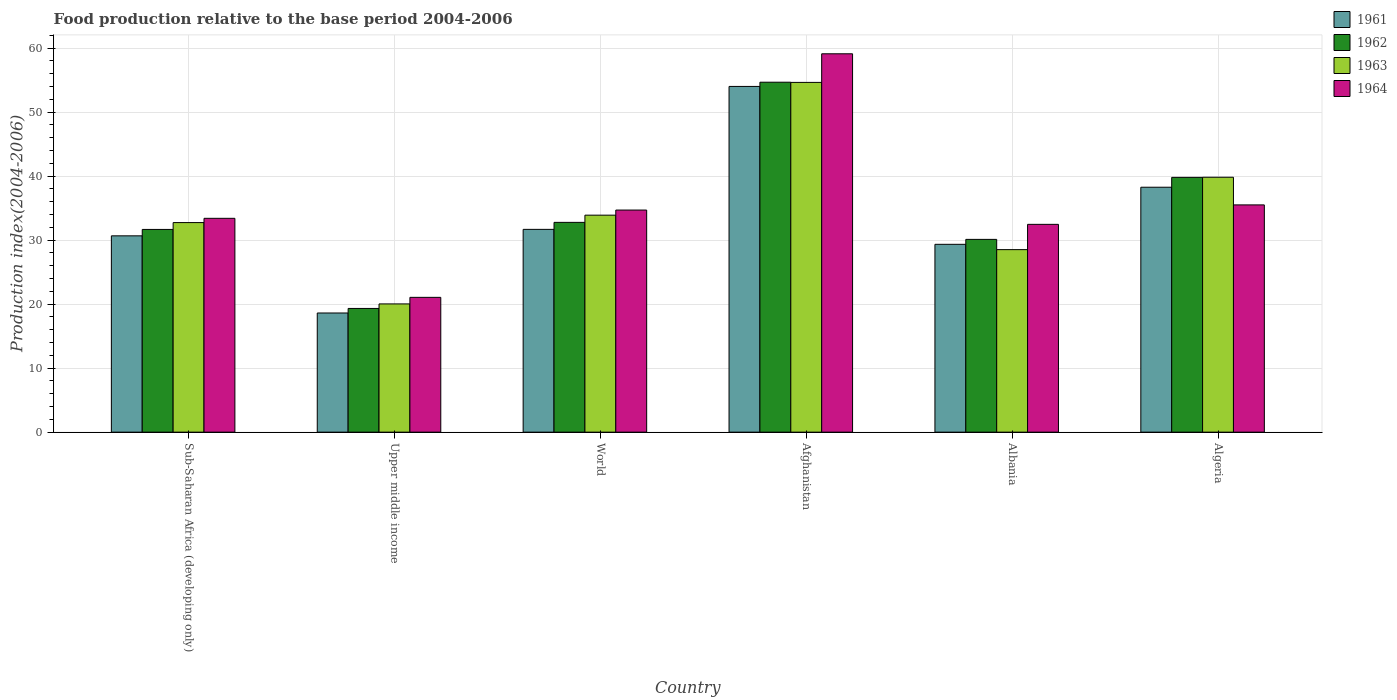How many different coloured bars are there?
Your response must be concise. 4. Are the number of bars per tick equal to the number of legend labels?
Keep it short and to the point. Yes. How many bars are there on the 2nd tick from the left?
Offer a very short reply. 4. How many bars are there on the 1st tick from the right?
Provide a succinct answer. 4. What is the label of the 4th group of bars from the left?
Your answer should be compact. Afghanistan. In how many cases, is the number of bars for a given country not equal to the number of legend labels?
Your answer should be compact. 0. What is the food production index in 1961 in Algeria?
Your response must be concise. 38.27. Across all countries, what is the maximum food production index in 1962?
Offer a very short reply. 54.68. Across all countries, what is the minimum food production index in 1963?
Provide a succinct answer. 20.04. In which country was the food production index in 1961 maximum?
Offer a terse response. Afghanistan. In which country was the food production index in 1963 minimum?
Give a very brief answer. Upper middle income. What is the total food production index in 1963 in the graph?
Give a very brief answer. 209.69. What is the difference between the food production index in 1963 in Sub-Saharan Africa (developing only) and that in World?
Give a very brief answer. -1.16. What is the difference between the food production index in 1964 in Algeria and the food production index in 1962 in Albania?
Give a very brief answer. 5.39. What is the average food production index in 1961 per country?
Offer a very short reply. 33.77. What is the difference between the food production index of/in 1961 and food production index of/in 1964 in World?
Provide a short and direct response. -3.02. What is the ratio of the food production index in 1962 in Upper middle income to that in World?
Ensure brevity in your answer.  0.59. What is the difference between the highest and the second highest food production index in 1961?
Your answer should be very brief. -15.75. What is the difference between the highest and the lowest food production index in 1961?
Give a very brief answer. 35.4. In how many countries, is the food production index in 1962 greater than the average food production index in 1962 taken over all countries?
Keep it short and to the point. 2. Is the sum of the food production index in 1963 in Afghanistan and World greater than the maximum food production index in 1961 across all countries?
Make the answer very short. Yes. Is it the case that in every country, the sum of the food production index in 1963 and food production index in 1961 is greater than the sum of food production index in 1962 and food production index in 1964?
Ensure brevity in your answer.  No. What does the 1st bar from the right in World represents?
Your answer should be compact. 1964. Is it the case that in every country, the sum of the food production index in 1962 and food production index in 1964 is greater than the food production index in 1963?
Ensure brevity in your answer.  Yes. How many bars are there?
Keep it short and to the point. 24. How many countries are there in the graph?
Give a very brief answer. 6. Are the values on the major ticks of Y-axis written in scientific E-notation?
Offer a terse response. No. Where does the legend appear in the graph?
Make the answer very short. Top right. How many legend labels are there?
Provide a succinct answer. 4. How are the legend labels stacked?
Ensure brevity in your answer.  Vertical. What is the title of the graph?
Your answer should be compact. Food production relative to the base period 2004-2006. Does "2003" appear as one of the legend labels in the graph?
Give a very brief answer. No. What is the label or title of the Y-axis?
Provide a short and direct response. Production index(2004-2006). What is the Production index(2004-2006) of 1961 in Sub-Saharan Africa (developing only)?
Provide a short and direct response. 30.68. What is the Production index(2004-2006) in 1962 in Sub-Saharan Africa (developing only)?
Your answer should be compact. 31.68. What is the Production index(2004-2006) of 1963 in Sub-Saharan Africa (developing only)?
Offer a very short reply. 32.75. What is the Production index(2004-2006) in 1964 in Sub-Saharan Africa (developing only)?
Ensure brevity in your answer.  33.41. What is the Production index(2004-2006) of 1961 in Upper middle income?
Provide a succinct answer. 18.62. What is the Production index(2004-2006) in 1962 in Upper middle income?
Provide a short and direct response. 19.33. What is the Production index(2004-2006) of 1963 in Upper middle income?
Offer a terse response. 20.04. What is the Production index(2004-2006) in 1964 in Upper middle income?
Offer a terse response. 21.06. What is the Production index(2004-2006) of 1961 in World?
Your response must be concise. 31.69. What is the Production index(2004-2006) in 1962 in World?
Your answer should be compact. 32.78. What is the Production index(2004-2006) of 1963 in World?
Offer a very short reply. 33.91. What is the Production index(2004-2006) in 1964 in World?
Your answer should be very brief. 34.7. What is the Production index(2004-2006) in 1961 in Afghanistan?
Offer a very short reply. 54.02. What is the Production index(2004-2006) of 1962 in Afghanistan?
Give a very brief answer. 54.68. What is the Production index(2004-2006) in 1963 in Afghanistan?
Provide a succinct answer. 54.65. What is the Production index(2004-2006) in 1964 in Afghanistan?
Provide a short and direct response. 59.12. What is the Production index(2004-2006) of 1961 in Albania?
Provide a short and direct response. 29.35. What is the Production index(2004-2006) in 1962 in Albania?
Provide a succinct answer. 30.12. What is the Production index(2004-2006) of 1963 in Albania?
Keep it short and to the point. 28.52. What is the Production index(2004-2006) of 1964 in Albania?
Make the answer very short. 32.47. What is the Production index(2004-2006) of 1961 in Algeria?
Ensure brevity in your answer.  38.27. What is the Production index(2004-2006) in 1962 in Algeria?
Offer a very short reply. 39.81. What is the Production index(2004-2006) of 1963 in Algeria?
Your answer should be very brief. 39.83. What is the Production index(2004-2006) of 1964 in Algeria?
Keep it short and to the point. 35.51. Across all countries, what is the maximum Production index(2004-2006) of 1961?
Your answer should be compact. 54.02. Across all countries, what is the maximum Production index(2004-2006) of 1962?
Ensure brevity in your answer.  54.68. Across all countries, what is the maximum Production index(2004-2006) in 1963?
Provide a succinct answer. 54.65. Across all countries, what is the maximum Production index(2004-2006) in 1964?
Provide a succinct answer. 59.12. Across all countries, what is the minimum Production index(2004-2006) of 1961?
Offer a very short reply. 18.62. Across all countries, what is the minimum Production index(2004-2006) of 1962?
Offer a very short reply. 19.33. Across all countries, what is the minimum Production index(2004-2006) in 1963?
Provide a short and direct response. 20.04. Across all countries, what is the minimum Production index(2004-2006) of 1964?
Make the answer very short. 21.06. What is the total Production index(2004-2006) in 1961 in the graph?
Provide a succinct answer. 202.62. What is the total Production index(2004-2006) of 1962 in the graph?
Give a very brief answer. 208.39. What is the total Production index(2004-2006) of 1963 in the graph?
Make the answer very short. 209.69. What is the total Production index(2004-2006) of 1964 in the graph?
Provide a succinct answer. 216.28. What is the difference between the Production index(2004-2006) of 1961 in Sub-Saharan Africa (developing only) and that in Upper middle income?
Your answer should be compact. 12.06. What is the difference between the Production index(2004-2006) in 1962 in Sub-Saharan Africa (developing only) and that in Upper middle income?
Provide a succinct answer. 12.35. What is the difference between the Production index(2004-2006) of 1963 in Sub-Saharan Africa (developing only) and that in Upper middle income?
Your response must be concise. 12.71. What is the difference between the Production index(2004-2006) of 1964 in Sub-Saharan Africa (developing only) and that in Upper middle income?
Your answer should be compact. 12.35. What is the difference between the Production index(2004-2006) of 1961 in Sub-Saharan Africa (developing only) and that in World?
Give a very brief answer. -1.01. What is the difference between the Production index(2004-2006) in 1962 in Sub-Saharan Africa (developing only) and that in World?
Provide a succinct answer. -1.1. What is the difference between the Production index(2004-2006) in 1963 in Sub-Saharan Africa (developing only) and that in World?
Your answer should be compact. -1.16. What is the difference between the Production index(2004-2006) of 1964 in Sub-Saharan Africa (developing only) and that in World?
Ensure brevity in your answer.  -1.29. What is the difference between the Production index(2004-2006) in 1961 in Sub-Saharan Africa (developing only) and that in Afghanistan?
Provide a succinct answer. -23.34. What is the difference between the Production index(2004-2006) of 1962 in Sub-Saharan Africa (developing only) and that in Afghanistan?
Your response must be concise. -23. What is the difference between the Production index(2004-2006) of 1963 in Sub-Saharan Africa (developing only) and that in Afghanistan?
Your answer should be compact. -21.91. What is the difference between the Production index(2004-2006) in 1964 in Sub-Saharan Africa (developing only) and that in Afghanistan?
Provide a succinct answer. -25.71. What is the difference between the Production index(2004-2006) in 1961 in Sub-Saharan Africa (developing only) and that in Albania?
Provide a succinct answer. 1.33. What is the difference between the Production index(2004-2006) in 1962 in Sub-Saharan Africa (developing only) and that in Albania?
Your answer should be very brief. 1.56. What is the difference between the Production index(2004-2006) of 1963 in Sub-Saharan Africa (developing only) and that in Albania?
Provide a succinct answer. 4.22. What is the difference between the Production index(2004-2006) in 1964 in Sub-Saharan Africa (developing only) and that in Albania?
Make the answer very short. 0.94. What is the difference between the Production index(2004-2006) in 1961 in Sub-Saharan Africa (developing only) and that in Algeria?
Your answer should be compact. -7.59. What is the difference between the Production index(2004-2006) in 1962 in Sub-Saharan Africa (developing only) and that in Algeria?
Give a very brief answer. -8.13. What is the difference between the Production index(2004-2006) of 1963 in Sub-Saharan Africa (developing only) and that in Algeria?
Ensure brevity in your answer.  -7.08. What is the difference between the Production index(2004-2006) of 1964 in Sub-Saharan Africa (developing only) and that in Algeria?
Your answer should be very brief. -2.1. What is the difference between the Production index(2004-2006) in 1961 in Upper middle income and that in World?
Ensure brevity in your answer.  -13.07. What is the difference between the Production index(2004-2006) of 1962 in Upper middle income and that in World?
Keep it short and to the point. -13.45. What is the difference between the Production index(2004-2006) in 1963 in Upper middle income and that in World?
Ensure brevity in your answer.  -13.87. What is the difference between the Production index(2004-2006) of 1964 in Upper middle income and that in World?
Keep it short and to the point. -13.64. What is the difference between the Production index(2004-2006) in 1961 in Upper middle income and that in Afghanistan?
Keep it short and to the point. -35.4. What is the difference between the Production index(2004-2006) in 1962 in Upper middle income and that in Afghanistan?
Provide a succinct answer. -35.35. What is the difference between the Production index(2004-2006) in 1963 in Upper middle income and that in Afghanistan?
Offer a terse response. -34.61. What is the difference between the Production index(2004-2006) of 1964 in Upper middle income and that in Afghanistan?
Your answer should be very brief. -38.06. What is the difference between the Production index(2004-2006) of 1961 in Upper middle income and that in Albania?
Your answer should be compact. -10.73. What is the difference between the Production index(2004-2006) of 1962 in Upper middle income and that in Albania?
Offer a terse response. -10.79. What is the difference between the Production index(2004-2006) in 1963 in Upper middle income and that in Albania?
Ensure brevity in your answer.  -8.48. What is the difference between the Production index(2004-2006) of 1964 in Upper middle income and that in Albania?
Offer a very short reply. -11.41. What is the difference between the Production index(2004-2006) in 1961 in Upper middle income and that in Algeria?
Offer a terse response. -19.65. What is the difference between the Production index(2004-2006) in 1962 in Upper middle income and that in Algeria?
Your answer should be compact. -20.48. What is the difference between the Production index(2004-2006) in 1963 in Upper middle income and that in Algeria?
Provide a succinct answer. -19.79. What is the difference between the Production index(2004-2006) of 1964 in Upper middle income and that in Algeria?
Give a very brief answer. -14.45. What is the difference between the Production index(2004-2006) in 1961 in World and that in Afghanistan?
Offer a very short reply. -22.33. What is the difference between the Production index(2004-2006) in 1962 in World and that in Afghanistan?
Offer a very short reply. -21.9. What is the difference between the Production index(2004-2006) in 1963 in World and that in Afghanistan?
Provide a succinct answer. -20.74. What is the difference between the Production index(2004-2006) of 1964 in World and that in Afghanistan?
Keep it short and to the point. -24.42. What is the difference between the Production index(2004-2006) in 1961 in World and that in Albania?
Offer a very short reply. 2.34. What is the difference between the Production index(2004-2006) in 1962 in World and that in Albania?
Your answer should be very brief. 2.66. What is the difference between the Production index(2004-2006) in 1963 in World and that in Albania?
Offer a very short reply. 5.39. What is the difference between the Production index(2004-2006) of 1964 in World and that in Albania?
Your response must be concise. 2.23. What is the difference between the Production index(2004-2006) in 1961 in World and that in Algeria?
Ensure brevity in your answer.  -6.58. What is the difference between the Production index(2004-2006) of 1962 in World and that in Algeria?
Provide a short and direct response. -7.03. What is the difference between the Production index(2004-2006) of 1963 in World and that in Algeria?
Offer a terse response. -5.92. What is the difference between the Production index(2004-2006) of 1964 in World and that in Algeria?
Give a very brief answer. -0.81. What is the difference between the Production index(2004-2006) in 1961 in Afghanistan and that in Albania?
Your response must be concise. 24.67. What is the difference between the Production index(2004-2006) of 1962 in Afghanistan and that in Albania?
Provide a succinct answer. 24.56. What is the difference between the Production index(2004-2006) in 1963 in Afghanistan and that in Albania?
Ensure brevity in your answer.  26.13. What is the difference between the Production index(2004-2006) of 1964 in Afghanistan and that in Albania?
Your answer should be compact. 26.65. What is the difference between the Production index(2004-2006) of 1961 in Afghanistan and that in Algeria?
Keep it short and to the point. 15.75. What is the difference between the Production index(2004-2006) in 1962 in Afghanistan and that in Algeria?
Provide a short and direct response. 14.87. What is the difference between the Production index(2004-2006) in 1963 in Afghanistan and that in Algeria?
Provide a short and direct response. 14.82. What is the difference between the Production index(2004-2006) in 1964 in Afghanistan and that in Algeria?
Your answer should be very brief. 23.61. What is the difference between the Production index(2004-2006) in 1961 in Albania and that in Algeria?
Offer a terse response. -8.92. What is the difference between the Production index(2004-2006) in 1962 in Albania and that in Algeria?
Your answer should be compact. -9.69. What is the difference between the Production index(2004-2006) of 1963 in Albania and that in Algeria?
Ensure brevity in your answer.  -11.31. What is the difference between the Production index(2004-2006) in 1964 in Albania and that in Algeria?
Your response must be concise. -3.04. What is the difference between the Production index(2004-2006) of 1961 in Sub-Saharan Africa (developing only) and the Production index(2004-2006) of 1962 in Upper middle income?
Your answer should be compact. 11.35. What is the difference between the Production index(2004-2006) of 1961 in Sub-Saharan Africa (developing only) and the Production index(2004-2006) of 1963 in Upper middle income?
Keep it short and to the point. 10.64. What is the difference between the Production index(2004-2006) in 1961 in Sub-Saharan Africa (developing only) and the Production index(2004-2006) in 1964 in Upper middle income?
Your answer should be compact. 9.61. What is the difference between the Production index(2004-2006) of 1962 in Sub-Saharan Africa (developing only) and the Production index(2004-2006) of 1963 in Upper middle income?
Your answer should be compact. 11.64. What is the difference between the Production index(2004-2006) of 1962 in Sub-Saharan Africa (developing only) and the Production index(2004-2006) of 1964 in Upper middle income?
Your answer should be very brief. 10.61. What is the difference between the Production index(2004-2006) in 1963 in Sub-Saharan Africa (developing only) and the Production index(2004-2006) in 1964 in Upper middle income?
Keep it short and to the point. 11.68. What is the difference between the Production index(2004-2006) of 1961 in Sub-Saharan Africa (developing only) and the Production index(2004-2006) of 1962 in World?
Your answer should be very brief. -2.1. What is the difference between the Production index(2004-2006) of 1961 in Sub-Saharan Africa (developing only) and the Production index(2004-2006) of 1963 in World?
Provide a succinct answer. -3.23. What is the difference between the Production index(2004-2006) in 1961 in Sub-Saharan Africa (developing only) and the Production index(2004-2006) in 1964 in World?
Give a very brief answer. -4.03. What is the difference between the Production index(2004-2006) of 1962 in Sub-Saharan Africa (developing only) and the Production index(2004-2006) of 1963 in World?
Ensure brevity in your answer.  -2.23. What is the difference between the Production index(2004-2006) of 1962 in Sub-Saharan Africa (developing only) and the Production index(2004-2006) of 1964 in World?
Offer a terse response. -3.03. What is the difference between the Production index(2004-2006) of 1963 in Sub-Saharan Africa (developing only) and the Production index(2004-2006) of 1964 in World?
Provide a succinct answer. -1.96. What is the difference between the Production index(2004-2006) in 1961 in Sub-Saharan Africa (developing only) and the Production index(2004-2006) in 1962 in Afghanistan?
Offer a terse response. -24. What is the difference between the Production index(2004-2006) of 1961 in Sub-Saharan Africa (developing only) and the Production index(2004-2006) of 1963 in Afghanistan?
Provide a short and direct response. -23.97. What is the difference between the Production index(2004-2006) of 1961 in Sub-Saharan Africa (developing only) and the Production index(2004-2006) of 1964 in Afghanistan?
Give a very brief answer. -28.44. What is the difference between the Production index(2004-2006) of 1962 in Sub-Saharan Africa (developing only) and the Production index(2004-2006) of 1963 in Afghanistan?
Provide a succinct answer. -22.97. What is the difference between the Production index(2004-2006) of 1962 in Sub-Saharan Africa (developing only) and the Production index(2004-2006) of 1964 in Afghanistan?
Offer a terse response. -27.44. What is the difference between the Production index(2004-2006) in 1963 in Sub-Saharan Africa (developing only) and the Production index(2004-2006) in 1964 in Afghanistan?
Offer a very short reply. -26.38. What is the difference between the Production index(2004-2006) of 1961 in Sub-Saharan Africa (developing only) and the Production index(2004-2006) of 1962 in Albania?
Keep it short and to the point. 0.56. What is the difference between the Production index(2004-2006) in 1961 in Sub-Saharan Africa (developing only) and the Production index(2004-2006) in 1963 in Albania?
Give a very brief answer. 2.16. What is the difference between the Production index(2004-2006) of 1961 in Sub-Saharan Africa (developing only) and the Production index(2004-2006) of 1964 in Albania?
Your response must be concise. -1.79. What is the difference between the Production index(2004-2006) in 1962 in Sub-Saharan Africa (developing only) and the Production index(2004-2006) in 1963 in Albania?
Your answer should be compact. 3.16. What is the difference between the Production index(2004-2006) of 1962 in Sub-Saharan Africa (developing only) and the Production index(2004-2006) of 1964 in Albania?
Provide a succinct answer. -0.79. What is the difference between the Production index(2004-2006) of 1963 in Sub-Saharan Africa (developing only) and the Production index(2004-2006) of 1964 in Albania?
Ensure brevity in your answer.  0.28. What is the difference between the Production index(2004-2006) of 1961 in Sub-Saharan Africa (developing only) and the Production index(2004-2006) of 1962 in Algeria?
Offer a terse response. -9.13. What is the difference between the Production index(2004-2006) in 1961 in Sub-Saharan Africa (developing only) and the Production index(2004-2006) in 1963 in Algeria?
Give a very brief answer. -9.15. What is the difference between the Production index(2004-2006) of 1961 in Sub-Saharan Africa (developing only) and the Production index(2004-2006) of 1964 in Algeria?
Give a very brief answer. -4.83. What is the difference between the Production index(2004-2006) of 1962 in Sub-Saharan Africa (developing only) and the Production index(2004-2006) of 1963 in Algeria?
Give a very brief answer. -8.15. What is the difference between the Production index(2004-2006) in 1962 in Sub-Saharan Africa (developing only) and the Production index(2004-2006) in 1964 in Algeria?
Offer a very short reply. -3.83. What is the difference between the Production index(2004-2006) of 1963 in Sub-Saharan Africa (developing only) and the Production index(2004-2006) of 1964 in Algeria?
Provide a succinct answer. -2.77. What is the difference between the Production index(2004-2006) in 1961 in Upper middle income and the Production index(2004-2006) in 1962 in World?
Give a very brief answer. -14.16. What is the difference between the Production index(2004-2006) of 1961 in Upper middle income and the Production index(2004-2006) of 1963 in World?
Make the answer very short. -15.29. What is the difference between the Production index(2004-2006) of 1961 in Upper middle income and the Production index(2004-2006) of 1964 in World?
Offer a terse response. -16.08. What is the difference between the Production index(2004-2006) in 1962 in Upper middle income and the Production index(2004-2006) in 1963 in World?
Your response must be concise. -14.58. What is the difference between the Production index(2004-2006) in 1962 in Upper middle income and the Production index(2004-2006) in 1964 in World?
Your answer should be very brief. -15.38. What is the difference between the Production index(2004-2006) in 1963 in Upper middle income and the Production index(2004-2006) in 1964 in World?
Offer a very short reply. -14.67. What is the difference between the Production index(2004-2006) in 1961 in Upper middle income and the Production index(2004-2006) in 1962 in Afghanistan?
Your answer should be compact. -36.06. What is the difference between the Production index(2004-2006) of 1961 in Upper middle income and the Production index(2004-2006) of 1963 in Afghanistan?
Keep it short and to the point. -36.03. What is the difference between the Production index(2004-2006) in 1961 in Upper middle income and the Production index(2004-2006) in 1964 in Afghanistan?
Your response must be concise. -40.5. What is the difference between the Production index(2004-2006) in 1962 in Upper middle income and the Production index(2004-2006) in 1963 in Afghanistan?
Provide a succinct answer. -35.32. What is the difference between the Production index(2004-2006) in 1962 in Upper middle income and the Production index(2004-2006) in 1964 in Afghanistan?
Keep it short and to the point. -39.79. What is the difference between the Production index(2004-2006) in 1963 in Upper middle income and the Production index(2004-2006) in 1964 in Afghanistan?
Give a very brief answer. -39.08. What is the difference between the Production index(2004-2006) in 1961 in Upper middle income and the Production index(2004-2006) in 1962 in Albania?
Provide a short and direct response. -11.5. What is the difference between the Production index(2004-2006) in 1961 in Upper middle income and the Production index(2004-2006) in 1963 in Albania?
Ensure brevity in your answer.  -9.9. What is the difference between the Production index(2004-2006) in 1961 in Upper middle income and the Production index(2004-2006) in 1964 in Albania?
Offer a terse response. -13.85. What is the difference between the Production index(2004-2006) in 1962 in Upper middle income and the Production index(2004-2006) in 1963 in Albania?
Offer a terse response. -9.19. What is the difference between the Production index(2004-2006) in 1962 in Upper middle income and the Production index(2004-2006) in 1964 in Albania?
Your answer should be very brief. -13.14. What is the difference between the Production index(2004-2006) of 1963 in Upper middle income and the Production index(2004-2006) of 1964 in Albania?
Your response must be concise. -12.43. What is the difference between the Production index(2004-2006) of 1961 in Upper middle income and the Production index(2004-2006) of 1962 in Algeria?
Make the answer very short. -21.19. What is the difference between the Production index(2004-2006) of 1961 in Upper middle income and the Production index(2004-2006) of 1963 in Algeria?
Give a very brief answer. -21.21. What is the difference between the Production index(2004-2006) in 1961 in Upper middle income and the Production index(2004-2006) in 1964 in Algeria?
Your response must be concise. -16.89. What is the difference between the Production index(2004-2006) in 1962 in Upper middle income and the Production index(2004-2006) in 1963 in Algeria?
Give a very brief answer. -20.5. What is the difference between the Production index(2004-2006) in 1962 in Upper middle income and the Production index(2004-2006) in 1964 in Algeria?
Your answer should be compact. -16.18. What is the difference between the Production index(2004-2006) of 1963 in Upper middle income and the Production index(2004-2006) of 1964 in Algeria?
Keep it short and to the point. -15.47. What is the difference between the Production index(2004-2006) of 1961 in World and the Production index(2004-2006) of 1962 in Afghanistan?
Your answer should be very brief. -22.99. What is the difference between the Production index(2004-2006) of 1961 in World and the Production index(2004-2006) of 1963 in Afghanistan?
Make the answer very short. -22.96. What is the difference between the Production index(2004-2006) in 1961 in World and the Production index(2004-2006) in 1964 in Afghanistan?
Offer a very short reply. -27.43. What is the difference between the Production index(2004-2006) of 1962 in World and the Production index(2004-2006) of 1963 in Afghanistan?
Provide a short and direct response. -21.87. What is the difference between the Production index(2004-2006) of 1962 in World and the Production index(2004-2006) of 1964 in Afghanistan?
Keep it short and to the point. -26.34. What is the difference between the Production index(2004-2006) in 1963 in World and the Production index(2004-2006) in 1964 in Afghanistan?
Your answer should be very brief. -25.21. What is the difference between the Production index(2004-2006) in 1961 in World and the Production index(2004-2006) in 1962 in Albania?
Your answer should be very brief. 1.57. What is the difference between the Production index(2004-2006) of 1961 in World and the Production index(2004-2006) of 1963 in Albania?
Provide a succinct answer. 3.17. What is the difference between the Production index(2004-2006) in 1961 in World and the Production index(2004-2006) in 1964 in Albania?
Ensure brevity in your answer.  -0.78. What is the difference between the Production index(2004-2006) of 1962 in World and the Production index(2004-2006) of 1963 in Albania?
Your answer should be compact. 4.26. What is the difference between the Production index(2004-2006) in 1962 in World and the Production index(2004-2006) in 1964 in Albania?
Your response must be concise. 0.31. What is the difference between the Production index(2004-2006) of 1963 in World and the Production index(2004-2006) of 1964 in Albania?
Offer a very short reply. 1.44. What is the difference between the Production index(2004-2006) of 1961 in World and the Production index(2004-2006) of 1962 in Algeria?
Ensure brevity in your answer.  -8.12. What is the difference between the Production index(2004-2006) in 1961 in World and the Production index(2004-2006) in 1963 in Algeria?
Your answer should be very brief. -8.14. What is the difference between the Production index(2004-2006) in 1961 in World and the Production index(2004-2006) in 1964 in Algeria?
Provide a succinct answer. -3.82. What is the difference between the Production index(2004-2006) of 1962 in World and the Production index(2004-2006) of 1963 in Algeria?
Ensure brevity in your answer.  -7.05. What is the difference between the Production index(2004-2006) in 1962 in World and the Production index(2004-2006) in 1964 in Algeria?
Keep it short and to the point. -2.73. What is the difference between the Production index(2004-2006) of 1963 in World and the Production index(2004-2006) of 1964 in Algeria?
Provide a short and direct response. -1.6. What is the difference between the Production index(2004-2006) of 1961 in Afghanistan and the Production index(2004-2006) of 1962 in Albania?
Ensure brevity in your answer.  23.9. What is the difference between the Production index(2004-2006) in 1961 in Afghanistan and the Production index(2004-2006) in 1964 in Albania?
Your answer should be compact. 21.55. What is the difference between the Production index(2004-2006) in 1962 in Afghanistan and the Production index(2004-2006) in 1963 in Albania?
Offer a terse response. 26.16. What is the difference between the Production index(2004-2006) of 1962 in Afghanistan and the Production index(2004-2006) of 1964 in Albania?
Your answer should be compact. 22.21. What is the difference between the Production index(2004-2006) in 1963 in Afghanistan and the Production index(2004-2006) in 1964 in Albania?
Provide a succinct answer. 22.18. What is the difference between the Production index(2004-2006) in 1961 in Afghanistan and the Production index(2004-2006) in 1962 in Algeria?
Your response must be concise. 14.21. What is the difference between the Production index(2004-2006) in 1961 in Afghanistan and the Production index(2004-2006) in 1963 in Algeria?
Your answer should be compact. 14.19. What is the difference between the Production index(2004-2006) of 1961 in Afghanistan and the Production index(2004-2006) of 1964 in Algeria?
Keep it short and to the point. 18.51. What is the difference between the Production index(2004-2006) in 1962 in Afghanistan and the Production index(2004-2006) in 1963 in Algeria?
Provide a short and direct response. 14.85. What is the difference between the Production index(2004-2006) in 1962 in Afghanistan and the Production index(2004-2006) in 1964 in Algeria?
Your answer should be compact. 19.17. What is the difference between the Production index(2004-2006) of 1963 in Afghanistan and the Production index(2004-2006) of 1964 in Algeria?
Ensure brevity in your answer.  19.14. What is the difference between the Production index(2004-2006) in 1961 in Albania and the Production index(2004-2006) in 1962 in Algeria?
Ensure brevity in your answer.  -10.46. What is the difference between the Production index(2004-2006) of 1961 in Albania and the Production index(2004-2006) of 1963 in Algeria?
Offer a terse response. -10.48. What is the difference between the Production index(2004-2006) of 1961 in Albania and the Production index(2004-2006) of 1964 in Algeria?
Your answer should be compact. -6.16. What is the difference between the Production index(2004-2006) in 1962 in Albania and the Production index(2004-2006) in 1963 in Algeria?
Offer a terse response. -9.71. What is the difference between the Production index(2004-2006) in 1962 in Albania and the Production index(2004-2006) in 1964 in Algeria?
Provide a succinct answer. -5.39. What is the difference between the Production index(2004-2006) of 1963 in Albania and the Production index(2004-2006) of 1964 in Algeria?
Provide a short and direct response. -6.99. What is the average Production index(2004-2006) in 1961 per country?
Your answer should be very brief. 33.77. What is the average Production index(2004-2006) of 1962 per country?
Offer a terse response. 34.73. What is the average Production index(2004-2006) of 1963 per country?
Your response must be concise. 34.95. What is the average Production index(2004-2006) in 1964 per country?
Provide a short and direct response. 36.05. What is the difference between the Production index(2004-2006) of 1961 and Production index(2004-2006) of 1962 in Sub-Saharan Africa (developing only)?
Provide a succinct answer. -1. What is the difference between the Production index(2004-2006) in 1961 and Production index(2004-2006) in 1963 in Sub-Saharan Africa (developing only)?
Provide a short and direct response. -2.07. What is the difference between the Production index(2004-2006) in 1961 and Production index(2004-2006) in 1964 in Sub-Saharan Africa (developing only)?
Your answer should be compact. -2.74. What is the difference between the Production index(2004-2006) in 1962 and Production index(2004-2006) in 1963 in Sub-Saharan Africa (developing only)?
Your answer should be very brief. -1.07. What is the difference between the Production index(2004-2006) of 1962 and Production index(2004-2006) of 1964 in Sub-Saharan Africa (developing only)?
Your answer should be compact. -1.74. What is the difference between the Production index(2004-2006) in 1961 and Production index(2004-2006) in 1962 in Upper middle income?
Provide a short and direct response. -0.71. What is the difference between the Production index(2004-2006) in 1961 and Production index(2004-2006) in 1963 in Upper middle income?
Offer a very short reply. -1.42. What is the difference between the Production index(2004-2006) of 1961 and Production index(2004-2006) of 1964 in Upper middle income?
Provide a succinct answer. -2.44. What is the difference between the Production index(2004-2006) in 1962 and Production index(2004-2006) in 1963 in Upper middle income?
Your answer should be very brief. -0.71. What is the difference between the Production index(2004-2006) of 1962 and Production index(2004-2006) of 1964 in Upper middle income?
Make the answer very short. -1.73. What is the difference between the Production index(2004-2006) in 1963 and Production index(2004-2006) in 1964 in Upper middle income?
Your answer should be very brief. -1.02. What is the difference between the Production index(2004-2006) in 1961 and Production index(2004-2006) in 1962 in World?
Give a very brief answer. -1.09. What is the difference between the Production index(2004-2006) of 1961 and Production index(2004-2006) of 1963 in World?
Keep it short and to the point. -2.22. What is the difference between the Production index(2004-2006) of 1961 and Production index(2004-2006) of 1964 in World?
Make the answer very short. -3.02. What is the difference between the Production index(2004-2006) in 1962 and Production index(2004-2006) in 1963 in World?
Your answer should be compact. -1.13. What is the difference between the Production index(2004-2006) of 1962 and Production index(2004-2006) of 1964 in World?
Provide a short and direct response. -1.92. What is the difference between the Production index(2004-2006) in 1963 and Production index(2004-2006) in 1964 in World?
Offer a very short reply. -0.8. What is the difference between the Production index(2004-2006) of 1961 and Production index(2004-2006) of 1962 in Afghanistan?
Your answer should be very brief. -0.66. What is the difference between the Production index(2004-2006) of 1961 and Production index(2004-2006) of 1963 in Afghanistan?
Provide a short and direct response. -0.63. What is the difference between the Production index(2004-2006) of 1961 and Production index(2004-2006) of 1964 in Afghanistan?
Your answer should be very brief. -5.1. What is the difference between the Production index(2004-2006) in 1962 and Production index(2004-2006) in 1964 in Afghanistan?
Provide a succinct answer. -4.44. What is the difference between the Production index(2004-2006) of 1963 and Production index(2004-2006) of 1964 in Afghanistan?
Your response must be concise. -4.47. What is the difference between the Production index(2004-2006) in 1961 and Production index(2004-2006) in 1962 in Albania?
Your answer should be compact. -0.77. What is the difference between the Production index(2004-2006) in 1961 and Production index(2004-2006) in 1963 in Albania?
Your response must be concise. 0.83. What is the difference between the Production index(2004-2006) of 1961 and Production index(2004-2006) of 1964 in Albania?
Your answer should be very brief. -3.12. What is the difference between the Production index(2004-2006) of 1962 and Production index(2004-2006) of 1964 in Albania?
Make the answer very short. -2.35. What is the difference between the Production index(2004-2006) in 1963 and Production index(2004-2006) in 1964 in Albania?
Your response must be concise. -3.95. What is the difference between the Production index(2004-2006) in 1961 and Production index(2004-2006) in 1962 in Algeria?
Your answer should be very brief. -1.54. What is the difference between the Production index(2004-2006) in 1961 and Production index(2004-2006) in 1963 in Algeria?
Give a very brief answer. -1.56. What is the difference between the Production index(2004-2006) of 1961 and Production index(2004-2006) of 1964 in Algeria?
Provide a succinct answer. 2.76. What is the difference between the Production index(2004-2006) of 1962 and Production index(2004-2006) of 1963 in Algeria?
Your answer should be very brief. -0.02. What is the difference between the Production index(2004-2006) in 1963 and Production index(2004-2006) in 1964 in Algeria?
Keep it short and to the point. 4.32. What is the ratio of the Production index(2004-2006) in 1961 in Sub-Saharan Africa (developing only) to that in Upper middle income?
Offer a very short reply. 1.65. What is the ratio of the Production index(2004-2006) in 1962 in Sub-Saharan Africa (developing only) to that in Upper middle income?
Keep it short and to the point. 1.64. What is the ratio of the Production index(2004-2006) of 1963 in Sub-Saharan Africa (developing only) to that in Upper middle income?
Give a very brief answer. 1.63. What is the ratio of the Production index(2004-2006) of 1964 in Sub-Saharan Africa (developing only) to that in Upper middle income?
Ensure brevity in your answer.  1.59. What is the ratio of the Production index(2004-2006) in 1961 in Sub-Saharan Africa (developing only) to that in World?
Ensure brevity in your answer.  0.97. What is the ratio of the Production index(2004-2006) of 1962 in Sub-Saharan Africa (developing only) to that in World?
Provide a succinct answer. 0.97. What is the ratio of the Production index(2004-2006) in 1963 in Sub-Saharan Africa (developing only) to that in World?
Provide a succinct answer. 0.97. What is the ratio of the Production index(2004-2006) in 1964 in Sub-Saharan Africa (developing only) to that in World?
Ensure brevity in your answer.  0.96. What is the ratio of the Production index(2004-2006) of 1961 in Sub-Saharan Africa (developing only) to that in Afghanistan?
Your answer should be very brief. 0.57. What is the ratio of the Production index(2004-2006) of 1962 in Sub-Saharan Africa (developing only) to that in Afghanistan?
Offer a terse response. 0.58. What is the ratio of the Production index(2004-2006) in 1963 in Sub-Saharan Africa (developing only) to that in Afghanistan?
Your answer should be very brief. 0.6. What is the ratio of the Production index(2004-2006) in 1964 in Sub-Saharan Africa (developing only) to that in Afghanistan?
Your answer should be very brief. 0.57. What is the ratio of the Production index(2004-2006) of 1961 in Sub-Saharan Africa (developing only) to that in Albania?
Provide a succinct answer. 1.05. What is the ratio of the Production index(2004-2006) of 1962 in Sub-Saharan Africa (developing only) to that in Albania?
Provide a succinct answer. 1.05. What is the ratio of the Production index(2004-2006) of 1963 in Sub-Saharan Africa (developing only) to that in Albania?
Your response must be concise. 1.15. What is the ratio of the Production index(2004-2006) of 1961 in Sub-Saharan Africa (developing only) to that in Algeria?
Your answer should be compact. 0.8. What is the ratio of the Production index(2004-2006) of 1962 in Sub-Saharan Africa (developing only) to that in Algeria?
Ensure brevity in your answer.  0.8. What is the ratio of the Production index(2004-2006) of 1963 in Sub-Saharan Africa (developing only) to that in Algeria?
Your answer should be compact. 0.82. What is the ratio of the Production index(2004-2006) of 1964 in Sub-Saharan Africa (developing only) to that in Algeria?
Provide a short and direct response. 0.94. What is the ratio of the Production index(2004-2006) in 1961 in Upper middle income to that in World?
Provide a succinct answer. 0.59. What is the ratio of the Production index(2004-2006) of 1962 in Upper middle income to that in World?
Your answer should be very brief. 0.59. What is the ratio of the Production index(2004-2006) of 1963 in Upper middle income to that in World?
Make the answer very short. 0.59. What is the ratio of the Production index(2004-2006) in 1964 in Upper middle income to that in World?
Offer a terse response. 0.61. What is the ratio of the Production index(2004-2006) in 1961 in Upper middle income to that in Afghanistan?
Provide a succinct answer. 0.34. What is the ratio of the Production index(2004-2006) of 1962 in Upper middle income to that in Afghanistan?
Offer a terse response. 0.35. What is the ratio of the Production index(2004-2006) in 1963 in Upper middle income to that in Afghanistan?
Your response must be concise. 0.37. What is the ratio of the Production index(2004-2006) in 1964 in Upper middle income to that in Afghanistan?
Provide a short and direct response. 0.36. What is the ratio of the Production index(2004-2006) of 1961 in Upper middle income to that in Albania?
Your answer should be compact. 0.63. What is the ratio of the Production index(2004-2006) in 1962 in Upper middle income to that in Albania?
Give a very brief answer. 0.64. What is the ratio of the Production index(2004-2006) in 1963 in Upper middle income to that in Albania?
Your answer should be very brief. 0.7. What is the ratio of the Production index(2004-2006) in 1964 in Upper middle income to that in Albania?
Ensure brevity in your answer.  0.65. What is the ratio of the Production index(2004-2006) in 1961 in Upper middle income to that in Algeria?
Offer a terse response. 0.49. What is the ratio of the Production index(2004-2006) in 1962 in Upper middle income to that in Algeria?
Keep it short and to the point. 0.49. What is the ratio of the Production index(2004-2006) in 1963 in Upper middle income to that in Algeria?
Offer a terse response. 0.5. What is the ratio of the Production index(2004-2006) in 1964 in Upper middle income to that in Algeria?
Ensure brevity in your answer.  0.59. What is the ratio of the Production index(2004-2006) of 1961 in World to that in Afghanistan?
Your answer should be compact. 0.59. What is the ratio of the Production index(2004-2006) in 1962 in World to that in Afghanistan?
Make the answer very short. 0.6. What is the ratio of the Production index(2004-2006) of 1963 in World to that in Afghanistan?
Ensure brevity in your answer.  0.62. What is the ratio of the Production index(2004-2006) of 1964 in World to that in Afghanistan?
Keep it short and to the point. 0.59. What is the ratio of the Production index(2004-2006) in 1961 in World to that in Albania?
Your answer should be very brief. 1.08. What is the ratio of the Production index(2004-2006) of 1962 in World to that in Albania?
Provide a succinct answer. 1.09. What is the ratio of the Production index(2004-2006) in 1963 in World to that in Albania?
Your response must be concise. 1.19. What is the ratio of the Production index(2004-2006) of 1964 in World to that in Albania?
Provide a succinct answer. 1.07. What is the ratio of the Production index(2004-2006) of 1961 in World to that in Algeria?
Make the answer very short. 0.83. What is the ratio of the Production index(2004-2006) of 1962 in World to that in Algeria?
Your answer should be compact. 0.82. What is the ratio of the Production index(2004-2006) of 1963 in World to that in Algeria?
Keep it short and to the point. 0.85. What is the ratio of the Production index(2004-2006) in 1964 in World to that in Algeria?
Your answer should be very brief. 0.98. What is the ratio of the Production index(2004-2006) of 1961 in Afghanistan to that in Albania?
Provide a succinct answer. 1.84. What is the ratio of the Production index(2004-2006) in 1962 in Afghanistan to that in Albania?
Make the answer very short. 1.82. What is the ratio of the Production index(2004-2006) of 1963 in Afghanistan to that in Albania?
Ensure brevity in your answer.  1.92. What is the ratio of the Production index(2004-2006) of 1964 in Afghanistan to that in Albania?
Give a very brief answer. 1.82. What is the ratio of the Production index(2004-2006) of 1961 in Afghanistan to that in Algeria?
Offer a very short reply. 1.41. What is the ratio of the Production index(2004-2006) of 1962 in Afghanistan to that in Algeria?
Offer a very short reply. 1.37. What is the ratio of the Production index(2004-2006) in 1963 in Afghanistan to that in Algeria?
Provide a short and direct response. 1.37. What is the ratio of the Production index(2004-2006) in 1964 in Afghanistan to that in Algeria?
Your response must be concise. 1.66. What is the ratio of the Production index(2004-2006) of 1961 in Albania to that in Algeria?
Make the answer very short. 0.77. What is the ratio of the Production index(2004-2006) of 1962 in Albania to that in Algeria?
Provide a short and direct response. 0.76. What is the ratio of the Production index(2004-2006) of 1963 in Albania to that in Algeria?
Provide a short and direct response. 0.72. What is the ratio of the Production index(2004-2006) in 1964 in Albania to that in Algeria?
Ensure brevity in your answer.  0.91. What is the difference between the highest and the second highest Production index(2004-2006) in 1961?
Give a very brief answer. 15.75. What is the difference between the highest and the second highest Production index(2004-2006) in 1962?
Provide a short and direct response. 14.87. What is the difference between the highest and the second highest Production index(2004-2006) of 1963?
Make the answer very short. 14.82. What is the difference between the highest and the second highest Production index(2004-2006) in 1964?
Provide a succinct answer. 23.61. What is the difference between the highest and the lowest Production index(2004-2006) in 1961?
Offer a very short reply. 35.4. What is the difference between the highest and the lowest Production index(2004-2006) in 1962?
Ensure brevity in your answer.  35.35. What is the difference between the highest and the lowest Production index(2004-2006) in 1963?
Keep it short and to the point. 34.61. What is the difference between the highest and the lowest Production index(2004-2006) of 1964?
Offer a very short reply. 38.06. 